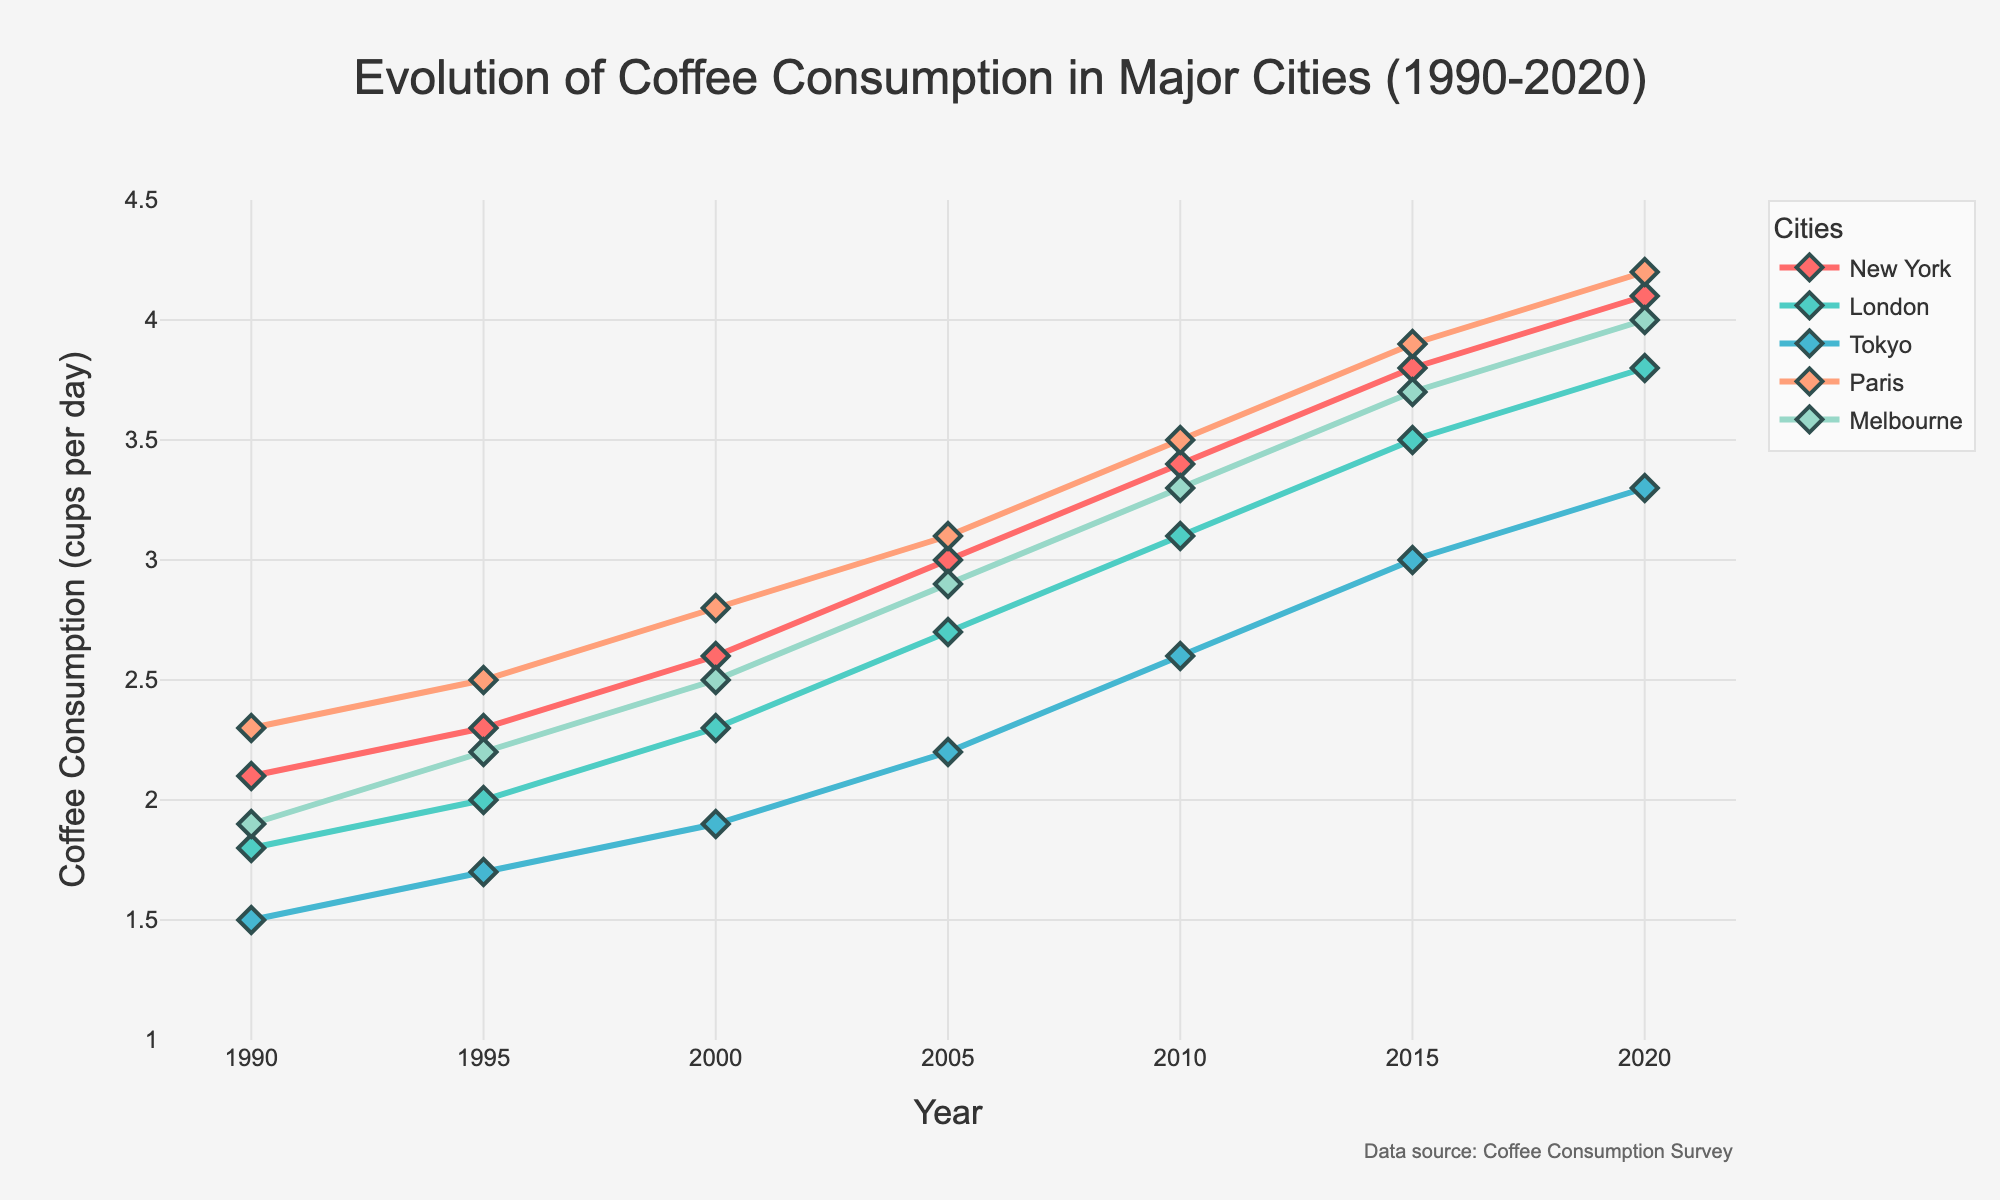What is the overall trend in coffee consumption for New York from 1990 to 2020? The plot shows a steady increase in coffee consumption for New York over the given period. The line representing New York has an upward slope throughout the entire range, indicating an overall increasing trend.
Answer: Increasing Which city had the highest coffee consumption in 2020? By examining the plot, the lines representing the coffee consumption in different cities intersect and vary over the years. In 2020, the highest point on the graph corresponds to New York, indicating that New York had the highest coffee consumption.
Answer: New York How does the coffee consumption in London in 1995 compare to that in Tokyo in the same year? Looking at the plot, the point corresponding to 1995 on London's line is slightly higher than the same point on Tokyo's line. This indicates that coffee consumption in London was greater than in Tokyo in 1995.
Answer: London What is the rate of increase in coffee consumption for Melbourne between 2000 and 2015? In 2000, Melbourne's coffee consumption was 2.5 cups/day, and it increased to 3.7 cups/day by 2015. The rate of increase can be calculated by (3.7 - 2.5) / (2015 - 2000), which gives (1.2) / 15 = 0.08 cups/day per year.
Answer: 0.08 cups/day per year Compare the changes in coffee consumption from 1990 to 2020 for Paris and Tokyo. Paris's coffee consumption increased from 2.3 cups/day in 1990 to 4.2 cups/day in 2020. Tokyo's consumption increased from 1.5 cups/day to 3.3 cups/day in the same period. The increase for Paris is 4.2 - 2.3 = 1.9 cups/day, and for Tokyo, it is 3.3 - 1.5 = 1.8 cups/day. Therefore, Paris had a slightly greater increase than Tokyo.
Answer: Paris had a greater increase When was the first time Melbourne's coffee consumption reached 3 cups/day? By observing the plot, Melbourne's line first intersects the 3 cups/day mark between the years 2005 and 2010. Therefore, Melbourne's coffee consumption first reached 3 cups/day in 2010.
Answer: 2010 At what year did Paris's coffee consumption surpass that of Tokyo? Tracing the lines representing Paris and Tokyo, Paris's coffee consumption surpasses Tokyo's around the year 1995.
Answer: 1995 In which year did all cities have a coffee consumption of at least 2 cups/day? According to the plot, by the year 2005, the lines representing all cities (New York, London, Tokyo, Paris, Melbourne) are above the 2 cups/day mark.
Answer: 2005 What is the average coffee consumption in 2010 among the five cities? The values for 2010 are New York: 3.4, London: 3.1, Tokyo: 2.6, Paris: 3.5, Melbourne: 3.3. The average is calculated as (3.4 + 3.1 + 2.6 + 3.5 + 3.3) / 5 = 15.9 / 5 = 3.18 cups/day.
Answer: 3.18 cups/day 